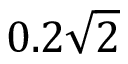Convert formula to latex. <formula><loc_0><loc_0><loc_500><loc_500>0 . 2 \sqrt { 2 }</formula> 